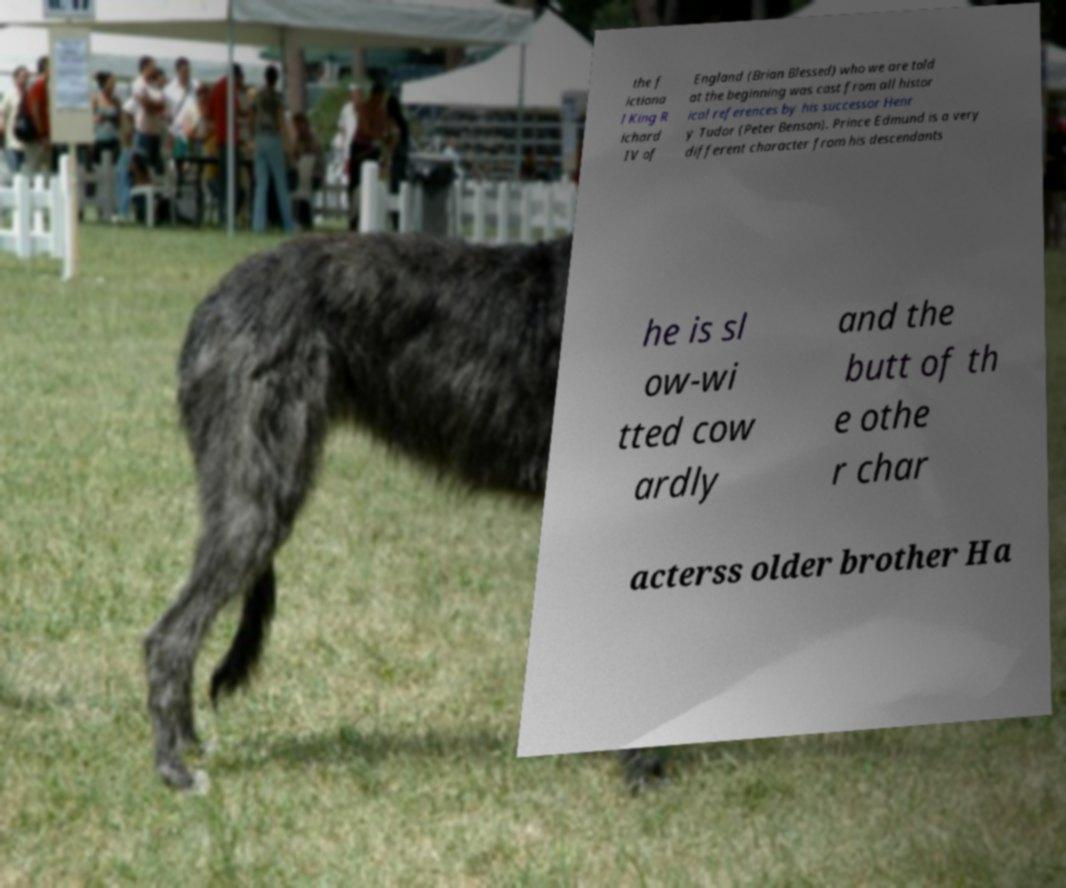Can you accurately transcribe the text from the provided image for me? the f ictiona l King R ichard IV of England (Brian Blessed) who we are told at the beginning was cast from all histor ical references by his successor Henr y Tudor (Peter Benson). Prince Edmund is a very different character from his descendants he is sl ow-wi tted cow ardly and the butt of th e othe r char acterss older brother Ha 